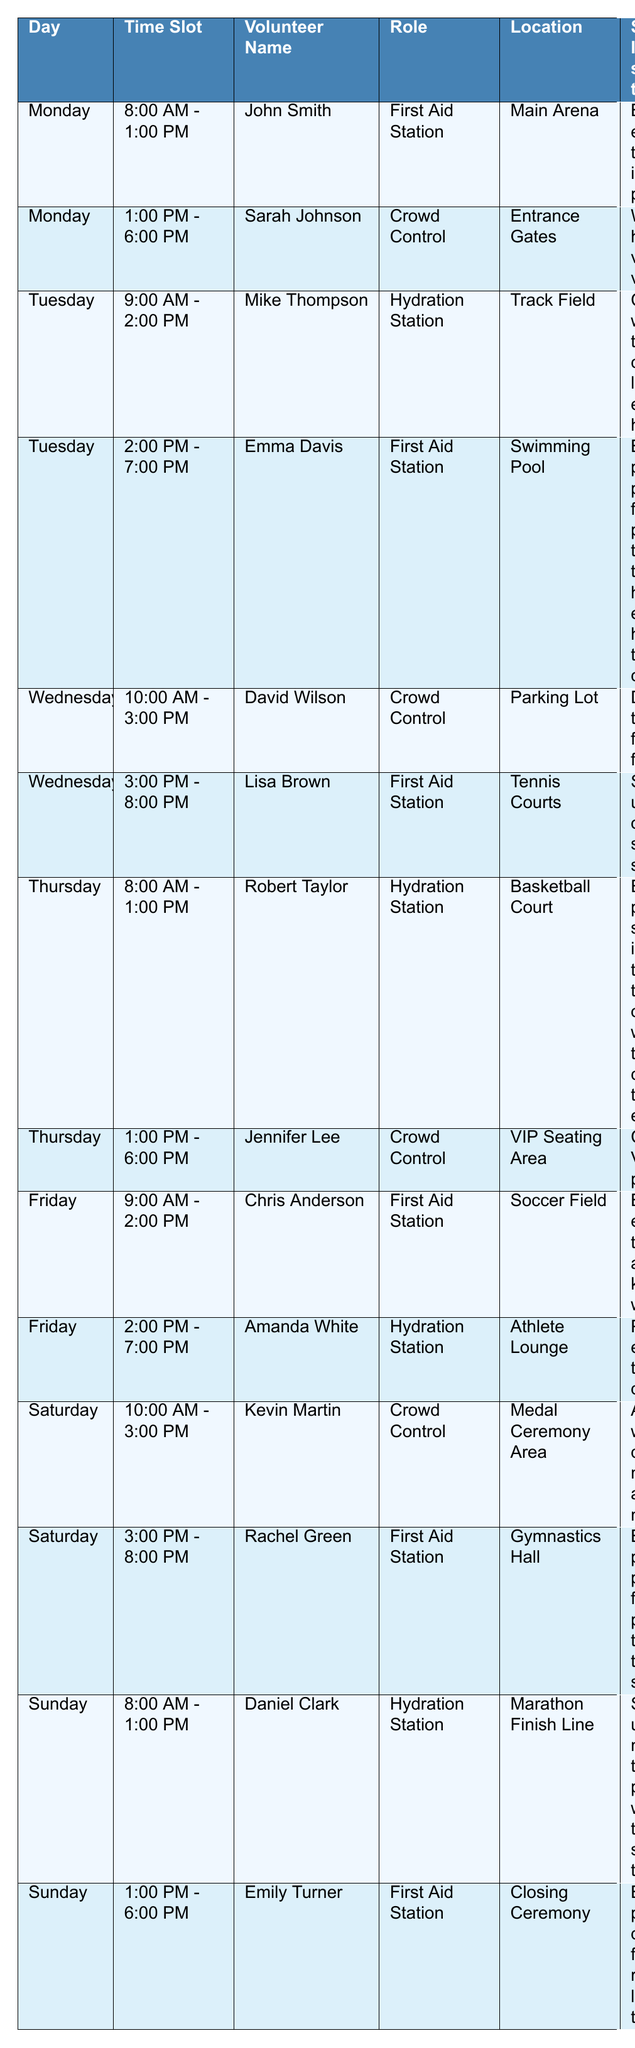What is the role of Mike Thompson? Mike Thompson's role can be found by looking under the "Volunteer Name" column for "Mike Thompson," which corresponds to the "Role" column for Tuesday from 9:00 AM - 2:00 PM. He is assigned to the Hydration Station.
Answer: Hydration Station Who is assigned to crowd control on Wednesday? To find the volunteer assigned to crowd control on Wednesday, look under the "Day" column for "Wednesday" and find the "Role" column that states "Crowd Control." The volunteer's name next to that role is David Wilson.
Answer: David Wilson On which day is the First Aid Station staffed by Rachel Green? By checking the table, we see that Rachel Green is assigned to the First Aid Station on Saturday from 3:00 PM - 8:00 PM.
Answer: Saturday How many volunteers are assigned to the Hydration Station throughout the week? We can count the entries under the "Role" column that indicate "Hydration Station." There are four volunteers assigned to this role: Mike Thompson, Robert Taylor, Daniel Clark, and Amanda White.
Answer: 4 Is Lisa Brown scheduled for any shifts before 3:00 PM on Wednesday? To verify this, look for entries on Wednesday and check the time slots. Lisa Brown's shift starts at 3:00 PM, meaning she does not have any shifts before that time.
Answer: No Which location has the most assigned volunteers for the First Aid Station? Looking at the "Location" associated with "First Aid Station," it shows that multiple areas are staffed, such as Main Arena, Swimming Pool, Tennis Courts, Soccer Field, Gymnastics Hall, and Closing Ceremony. Counting these shows that there are six different times and locations for the First Aid Station, making it the most recurring role.
Answer: 6 different locations What special instruction is given for the First Aid Station on Tuesday? Identify the entry for Tuesday when checking the "Role" column for "First Aid Station." The corresponding special instruction for Emma Davis is to "Be prepared for potential heat exhaustion cases."
Answer: Be prepared for potential heat exhaustion cases Which two roles are handled by volunteers from 2:00 PM to 7:00 PM? By examining the time slots, the roles assigned are "First Aid Station" covered by Emma Davis and "Hydration Station" covered by Amanda White during this time frame on Tuesday and Friday respectively.
Answer: First Aid Station and Hydration Station How many total hours are scheduled for volunteer shifts in the week? Adding up the hours for each volunteer shift based on the time slots: (5 hours x 7 volunteers on shifts that span several hours) provides the total. Counting all shifts from the table reveals a total of 42 hours planned across different roles.
Answer: 42 hours Can we say that all shifts are covered by different volunteers without any duplicates? Checking through the volunteer names in the schedule shows that each volunteer is assigned only once during the week, meaning no duplicates exist among the shifts.
Answer: Yes 